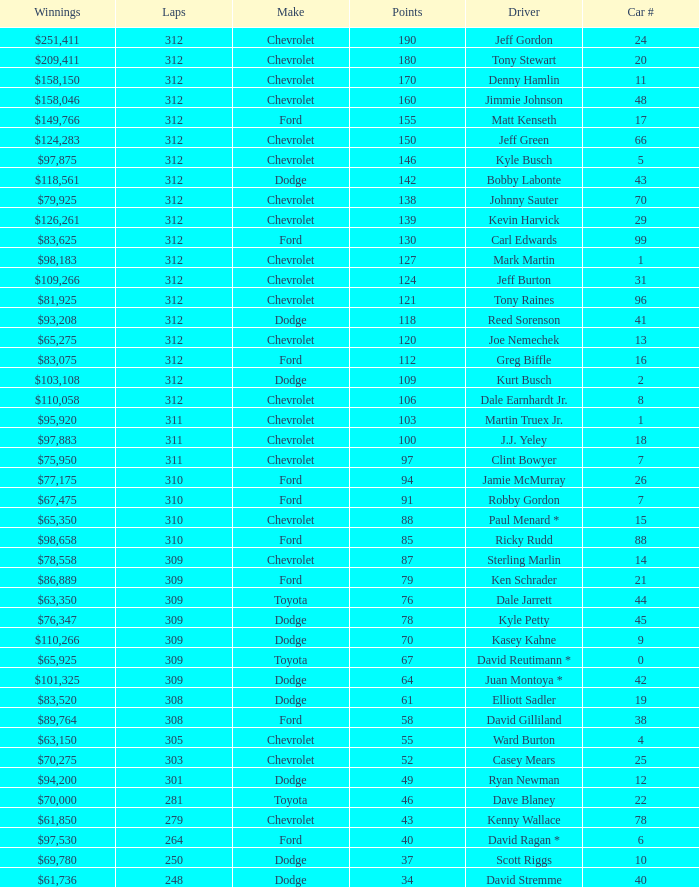What is the lowest number of laps for kyle petty with under 118 points? 309.0. 